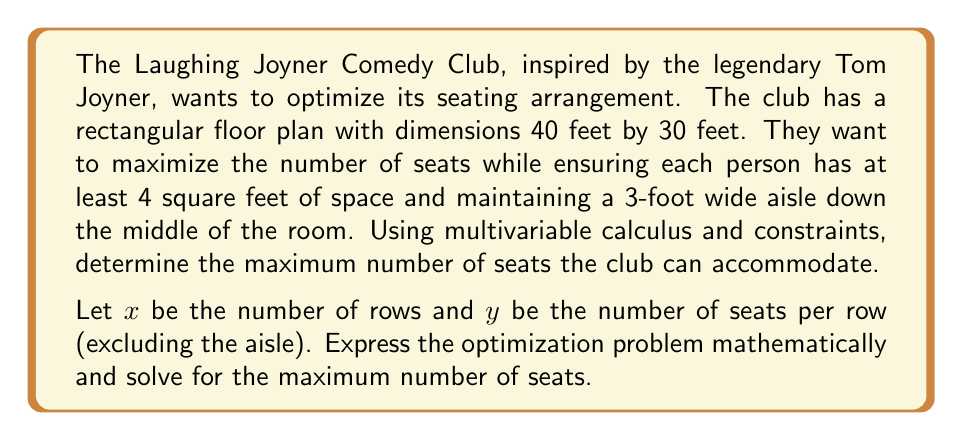Can you answer this question? Let's approach this step-by-step:

1) First, we need to set up our constraint equations:

   a) The total width of the room minus the aisle should accommodate the seats:
      $$(30 - 3) = 4y$$
      This simplifies to: $y = 6.75$

   b) The length of the room should accommodate the rows:
      $$40 = 4x$$
      This simplifies to: $x = 10$

2) Our objective function is the total number of seats:
   $$S(x,y) = 2xy$$ (multiplied by 2 because there are seats on both sides of the aisle)

3) Now, we have a constrained optimization problem. We can solve this using the method of Lagrange multipliers:

   $$L(x,y,\lambda_1,\lambda_2) = 2xy - \lambda_1(4x - 40) - \lambda_2(4y - 27)$$

4) Taking partial derivatives and setting them equal to zero:

   $$\frac{\partial L}{\partial x} = 2y - 4\lambda_1 = 0$$
   $$\frac{\partial L}{\partial y} = 2x - 4\lambda_2 = 0$$
   $$\frac{\partial L}{\partial \lambda_1} = 4x - 40 = 0$$
   $$\frac{\partial L}{\partial \lambda_2} = 4y - 27 = 0$$

5) From the last two equations, we can see that:
   $$x = 10$$ and $$y = 6.75$$

6) These values satisfy our original constraints, so they are our optimal solution.

7) The maximum number of seats is therefore:
   $$S(10, 6.75) = 2 * 10 * 6.75 = 135$$

8) However, since we can't have fractional seats, we need to round down:
   $$S(10, 6) = 2 * 10 * 6 = 120$$

Therefore, the maximum number of whole seats that can be accommodated is 120.
Answer: The Laughing Joyner Comedy Club can accommodate a maximum of 120 seats. 